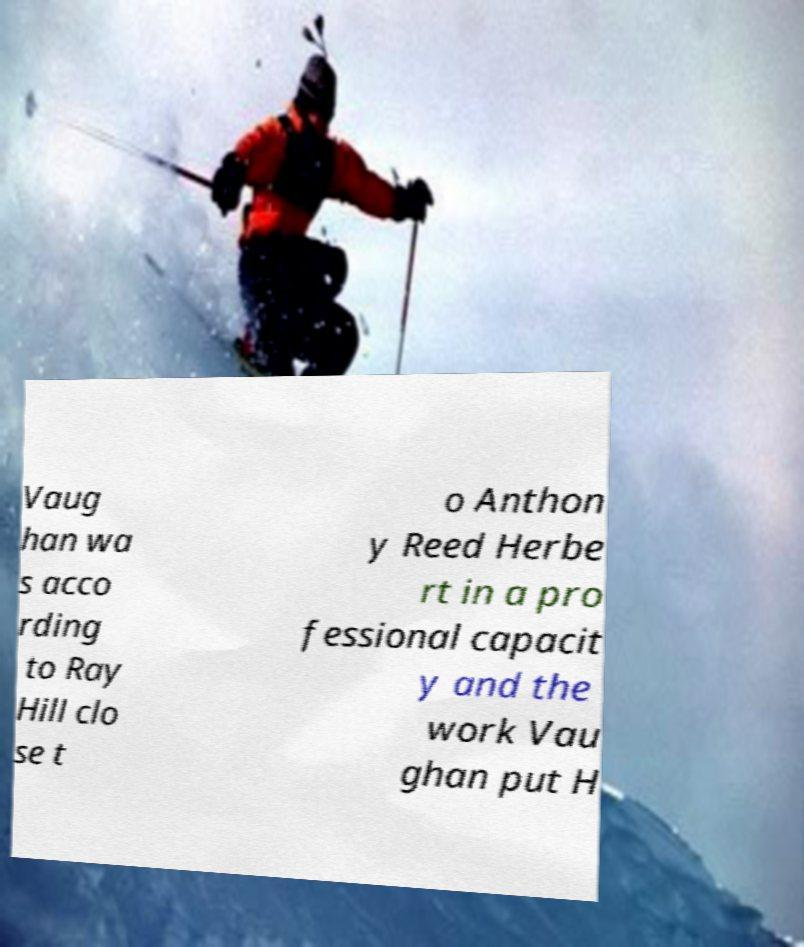Can you read and provide the text displayed in the image?This photo seems to have some interesting text. Can you extract and type it out for me? Vaug han wa s acco rding to Ray Hill clo se t o Anthon y Reed Herbe rt in a pro fessional capacit y and the work Vau ghan put H 